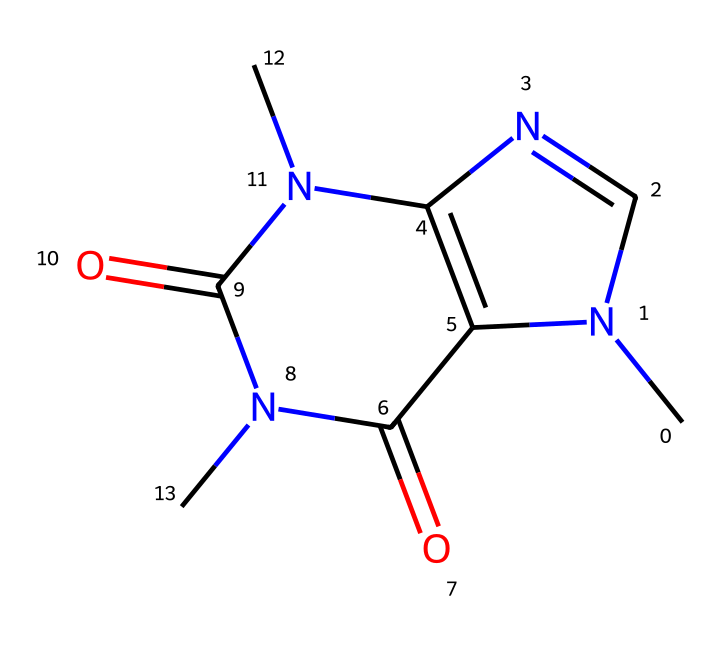What is the chemical name of this structure? The provided SMILES representation corresponds to caffeine, which is a central nervous system stimulant commonly found in energy drinks. The molecular structure depicts its arrangement of atoms and functional groups, confirming its identity as caffeine.
Answer: caffeine How many nitrogen atoms are present in this chemical structure? By analyzing the SMILES representation and counting the "N" symbols, there are a total of four nitrogen atoms in the structure, as indicated in the SMILES.
Answer: four What type of functional groups are present in this compound? The structure contains carbonyl groups, which are represented by the "=O" in the SMILES notation. These functional groups contribute to the overall properties of caffeine as a non-electrolyte.
Answer: carbonyl What is the total number of rings in the caffeine structure? In the provided SMILES, the 'C=N' and the cyclic nature of the rings signify that there are two distinct rings in the structure of caffeine, as validated by its cyclic connectivity.
Answer: two How many total carbon atoms are in this structure? Counting the "C" symbols in the SMILES representation gives a total of eight carbon atoms in the caffeine molecule, which is key to its structural identity.
Answer: eight What type of compound is caffeine classified as? Based on its chemical structure and properties, caffeine is classified as an alkaloid, which is a category of compounds that are typically basic and often derived from plant sources.
Answer: alkaloid 